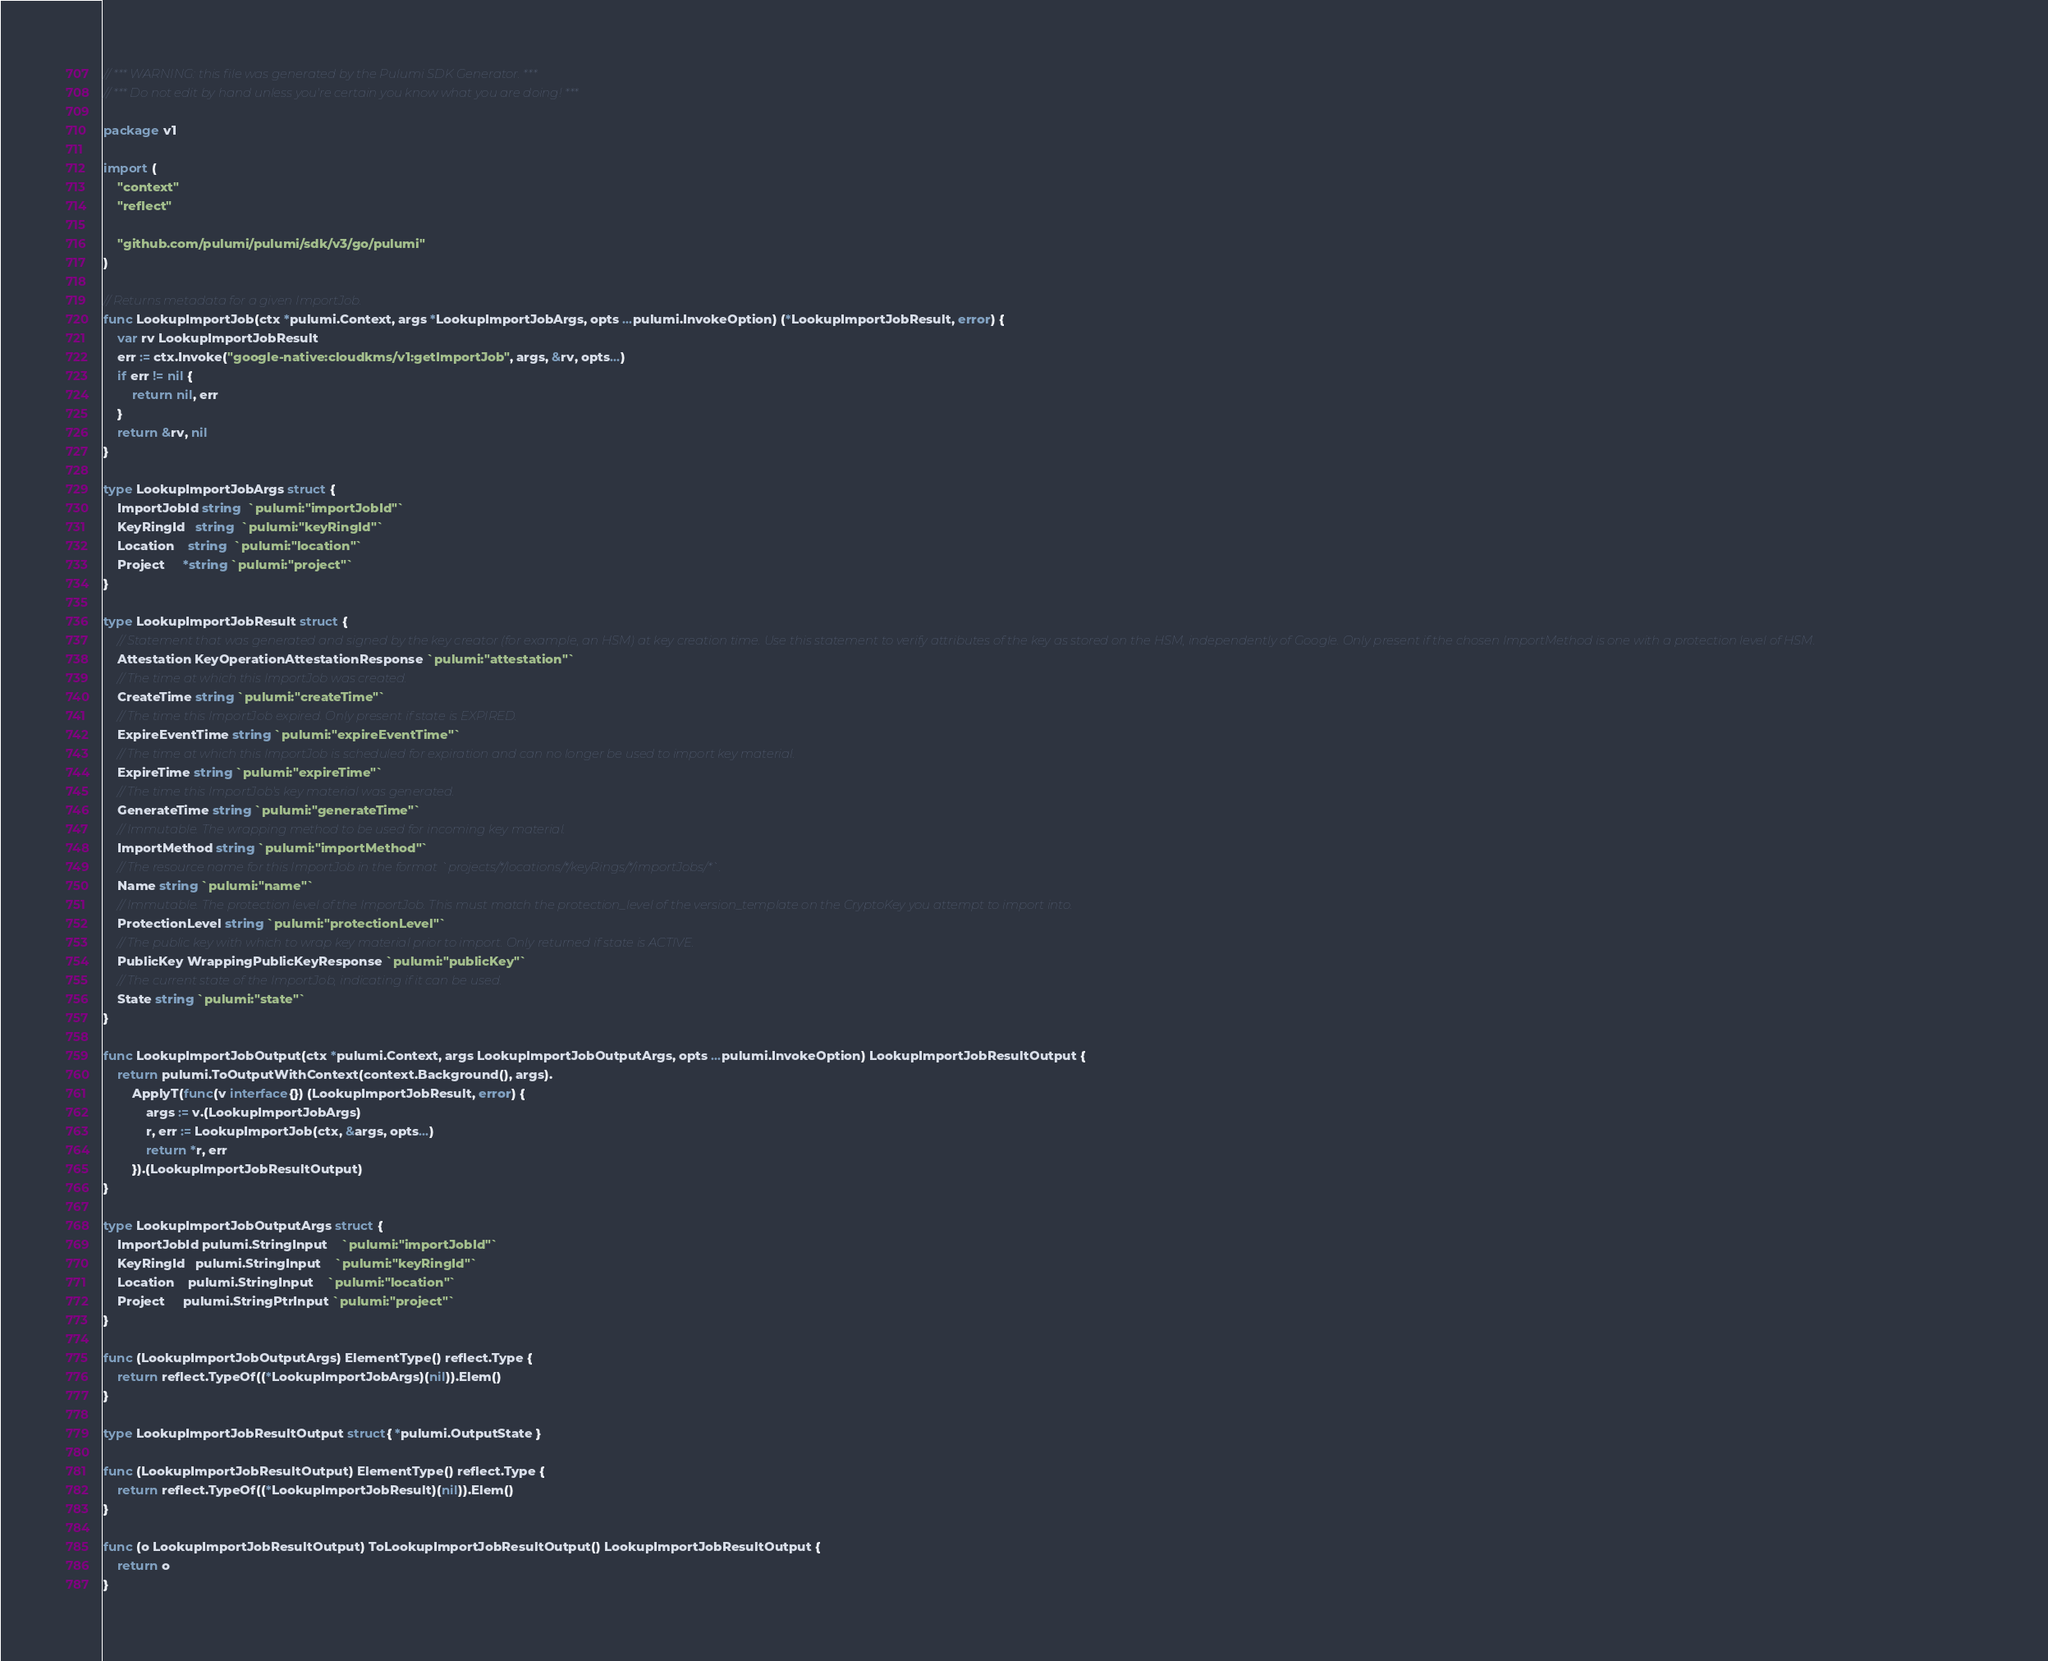Convert code to text. <code><loc_0><loc_0><loc_500><loc_500><_Go_>// *** WARNING: this file was generated by the Pulumi SDK Generator. ***
// *** Do not edit by hand unless you're certain you know what you are doing! ***

package v1

import (
	"context"
	"reflect"

	"github.com/pulumi/pulumi/sdk/v3/go/pulumi"
)

// Returns metadata for a given ImportJob.
func LookupImportJob(ctx *pulumi.Context, args *LookupImportJobArgs, opts ...pulumi.InvokeOption) (*LookupImportJobResult, error) {
	var rv LookupImportJobResult
	err := ctx.Invoke("google-native:cloudkms/v1:getImportJob", args, &rv, opts...)
	if err != nil {
		return nil, err
	}
	return &rv, nil
}

type LookupImportJobArgs struct {
	ImportJobId string  `pulumi:"importJobId"`
	KeyRingId   string  `pulumi:"keyRingId"`
	Location    string  `pulumi:"location"`
	Project     *string `pulumi:"project"`
}

type LookupImportJobResult struct {
	// Statement that was generated and signed by the key creator (for example, an HSM) at key creation time. Use this statement to verify attributes of the key as stored on the HSM, independently of Google. Only present if the chosen ImportMethod is one with a protection level of HSM.
	Attestation KeyOperationAttestationResponse `pulumi:"attestation"`
	// The time at which this ImportJob was created.
	CreateTime string `pulumi:"createTime"`
	// The time this ImportJob expired. Only present if state is EXPIRED.
	ExpireEventTime string `pulumi:"expireEventTime"`
	// The time at which this ImportJob is scheduled for expiration and can no longer be used to import key material.
	ExpireTime string `pulumi:"expireTime"`
	// The time this ImportJob's key material was generated.
	GenerateTime string `pulumi:"generateTime"`
	// Immutable. The wrapping method to be used for incoming key material.
	ImportMethod string `pulumi:"importMethod"`
	// The resource name for this ImportJob in the format `projects/*/locations/*/keyRings/*/importJobs/*`.
	Name string `pulumi:"name"`
	// Immutable. The protection level of the ImportJob. This must match the protection_level of the version_template on the CryptoKey you attempt to import into.
	ProtectionLevel string `pulumi:"protectionLevel"`
	// The public key with which to wrap key material prior to import. Only returned if state is ACTIVE.
	PublicKey WrappingPublicKeyResponse `pulumi:"publicKey"`
	// The current state of the ImportJob, indicating if it can be used.
	State string `pulumi:"state"`
}

func LookupImportJobOutput(ctx *pulumi.Context, args LookupImportJobOutputArgs, opts ...pulumi.InvokeOption) LookupImportJobResultOutput {
	return pulumi.ToOutputWithContext(context.Background(), args).
		ApplyT(func(v interface{}) (LookupImportJobResult, error) {
			args := v.(LookupImportJobArgs)
			r, err := LookupImportJob(ctx, &args, opts...)
			return *r, err
		}).(LookupImportJobResultOutput)
}

type LookupImportJobOutputArgs struct {
	ImportJobId pulumi.StringInput    `pulumi:"importJobId"`
	KeyRingId   pulumi.StringInput    `pulumi:"keyRingId"`
	Location    pulumi.StringInput    `pulumi:"location"`
	Project     pulumi.StringPtrInput `pulumi:"project"`
}

func (LookupImportJobOutputArgs) ElementType() reflect.Type {
	return reflect.TypeOf((*LookupImportJobArgs)(nil)).Elem()
}

type LookupImportJobResultOutput struct{ *pulumi.OutputState }

func (LookupImportJobResultOutput) ElementType() reflect.Type {
	return reflect.TypeOf((*LookupImportJobResult)(nil)).Elem()
}

func (o LookupImportJobResultOutput) ToLookupImportJobResultOutput() LookupImportJobResultOutput {
	return o
}
</code> 